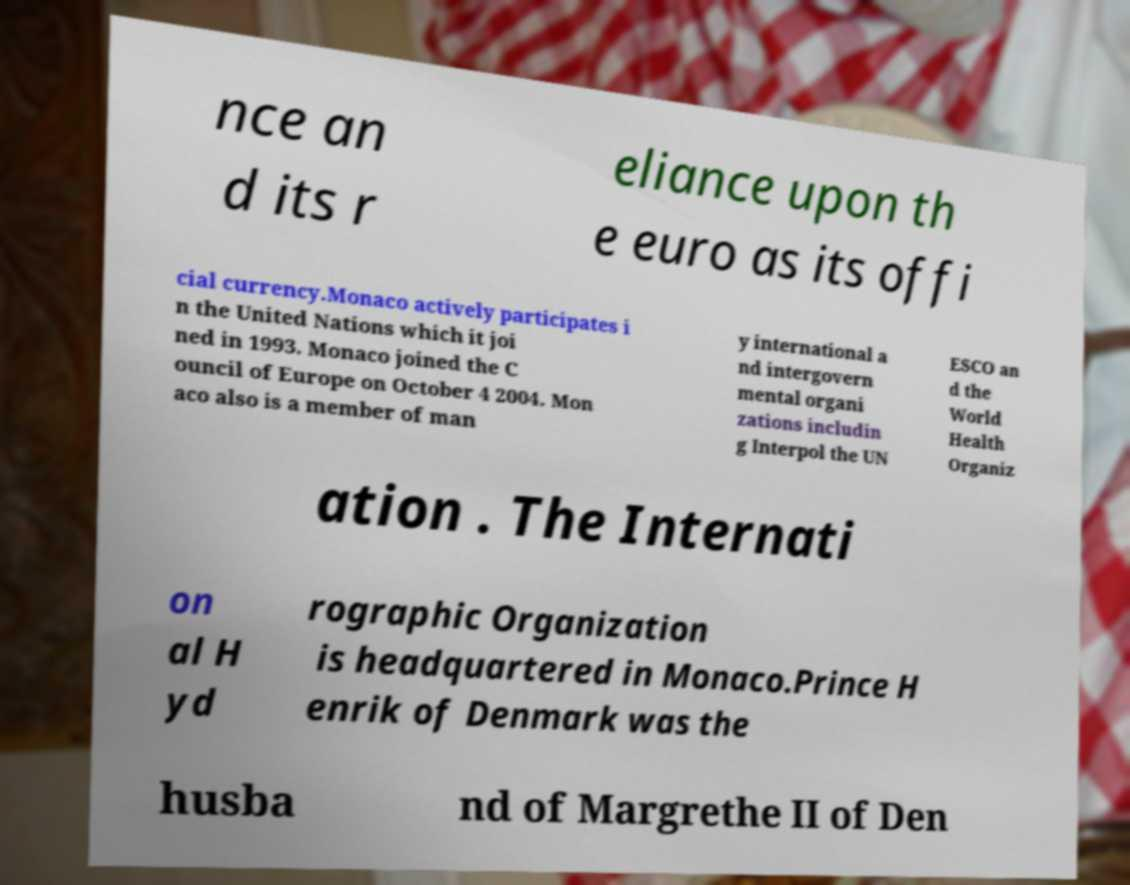For documentation purposes, I need the text within this image transcribed. Could you provide that? nce an d its r eliance upon th e euro as its offi cial currency.Monaco actively participates i n the United Nations which it joi ned in 1993. Monaco joined the C ouncil of Europe on October 4 2004. Mon aco also is a member of man y international a nd intergovern mental organi zations includin g Interpol the UN ESCO an d the World Health Organiz ation . The Internati on al H yd rographic Organization is headquartered in Monaco.Prince H enrik of Denmark was the husba nd of Margrethe II of Den 